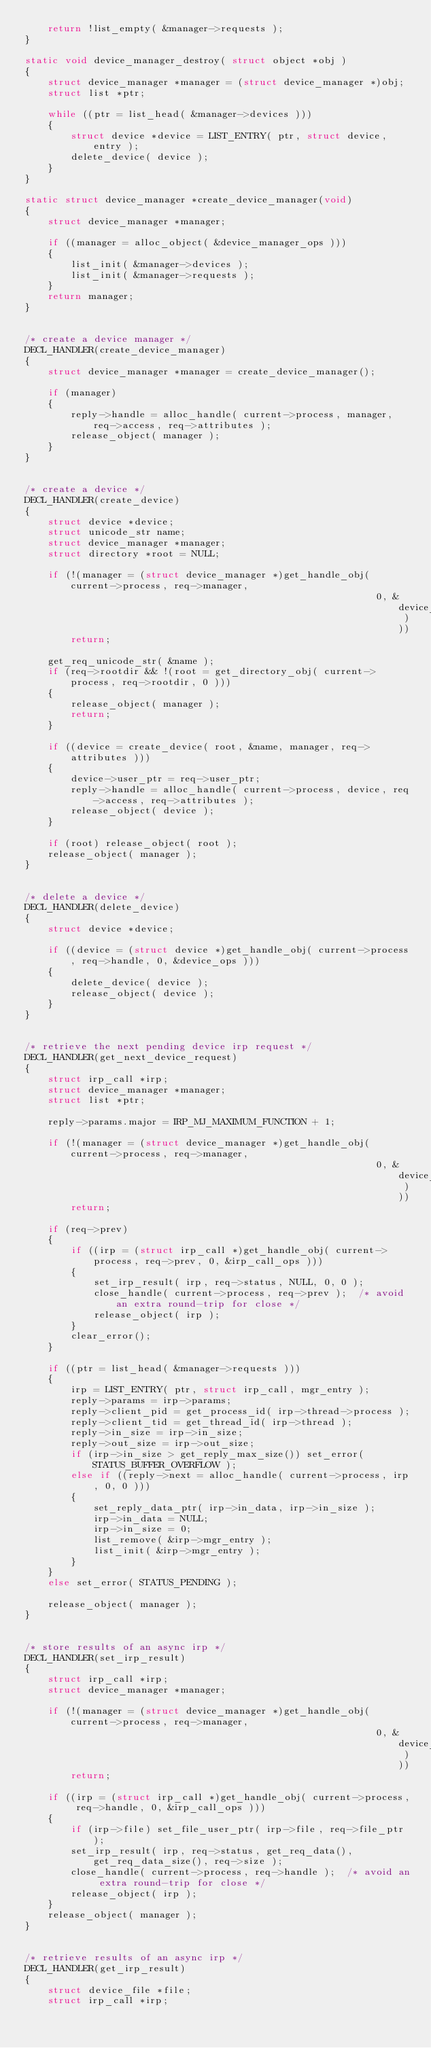Convert code to text. <code><loc_0><loc_0><loc_500><loc_500><_C_>    return !list_empty( &manager->requests );
}

static void device_manager_destroy( struct object *obj )
{
    struct device_manager *manager = (struct device_manager *)obj;
    struct list *ptr;

    while ((ptr = list_head( &manager->devices )))
    {
        struct device *device = LIST_ENTRY( ptr, struct device, entry );
        delete_device( device );
    }
}

static struct device_manager *create_device_manager(void)
{
    struct device_manager *manager;

    if ((manager = alloc_object( &device_manager_ops )))
    {
        list_init( &manager->devices );
        list_init( &manager->requests );
    }
    return manager;
}


/* create a device manager */
DECL_HANDLER(create_device_manager)
{
    struct device_manager *manager = create_device_manager();

    if (manager)
    {
        reply->handle = alloc_handle( current->process, manager, req->access, req->attributes );
        release_object( manager );
    }
}


/* create a device */
DECL_HANDLER(create_device)
{
    struct device *device;
    struct unicode_str name;
    struct device_manager *manager;
    struct directory *root = NULL;

    if (!(manager = (struct device_manager *)get_handle_obj( current->process, req->manager,
                                                             0, &device_manager_ops )))
        return;

    get_req_unicode_str( &name );
    if (req->rootdir && !(root = get_directory_obj( current->process, req->rootdir, 0 )))
    {
        release_object( manager );
        return;
    }

    if ((device = create_device( root, &name, manager, req->attributes )))
    {
        device->user_ptr = req->user_ptr;
        reply->handle = alloc_handle( current->process, device, req->access, req->attributes );
        release_object( device );
    }

    if (root) release_object( root );
    release_object( manager );
}


/* delete a device */
DECL_HANDLER(delete_device)
{
    struct device *device;

    if ((device = (struct device *)get_handle_obj( current->process, req->handle, 0, &device_ops )))
    {
        delete_device( device );
        release_object( device );
    }
}


/* retrieve the next pending device irp request */
DECL_HANDLER(get_next_device_request)
{
    struct irp_call *irp;
    struct device_manager *manager;
    struct list *ptr;

    reply->params.major = IRP_MJ_MAXIMUM_FUNCTION + 1;

    if (!(manager = (struct device_manager *)get_handle_obj( current->process, req->manager,
                                                             0, &device_manager_ops )))
        return;

    if (req->prev)
    {
        if ((irp = (struct irp_call *)get_handle_obj( current->process, req->prev, 0, &irp_call_ops )))
        {
            set_irp_result( irp, req->status, NULL, 0, 0 );
            close_handle( current->process, req->prev );  /* avoid an extra round-trip for close */
            release_object( irp );
        }
        clear_error();
    }

    if ((ptr = list_head( &manager->requests )))
    {
        irp = LIST_ENTRY( ptr, struct irp_call, mgr_entry );
        reply->params = irp->params;
        reply->client_pid = get_process_id( irp->thread->process );
        reply->client_tid = get_thread_id( irp->thread );
        reply->in_size = irp->in_size;
        reply->out_size = irp->out_size;
        if (irp->in_size > get_reply_max_size()) set_error( STATUS_BUFFER_OVERFLOW );
        else if ((reply->next = alloc_handle( current->process, irp, 0, 0 )))
        {
            set_reply_data_ptr( irp->in_data, irp->in_size );
            irp->in_data = NULL;
            irp->in_size = 0;
            list_remove( &irp->mgr_entry );
            list_init( &irp->mgr_entry );
        }
    }
    else set_error( STATUS_PENDING );

    release_object( manager );
}


/* store results of an async irp */
DECL_HANDLER(set_irp_result)
{
    struct irp_call *irp;
    struct device_manager *manager;

    if (!(manager = (struct device_manager *)get_handle_obj( current->process, req->manager,
                                                             0, &device_manager_ops )))
        return;

    if ((irp = (struct irp_call *)get_handle_obj( current->process, req->handle, 0, &irp_call_ops )))
    {
        if (irp->file) set_file_user_ptr( irp->file, req->file_ptr );
        set_irp_result( irp, req->status, get_req_data(), get_req_data_size(), req->size );
        close_handle( current->process, req->handle );  /* avoid an extra round-trip for close */
        release_object( irp );
    }
    release_object( manager );
}


/* retrieve results of an async irp */
DECL_HANDLER(get_irp_result)
{
    struct device_file *file;
    struct irp_call *irp;
</code> 